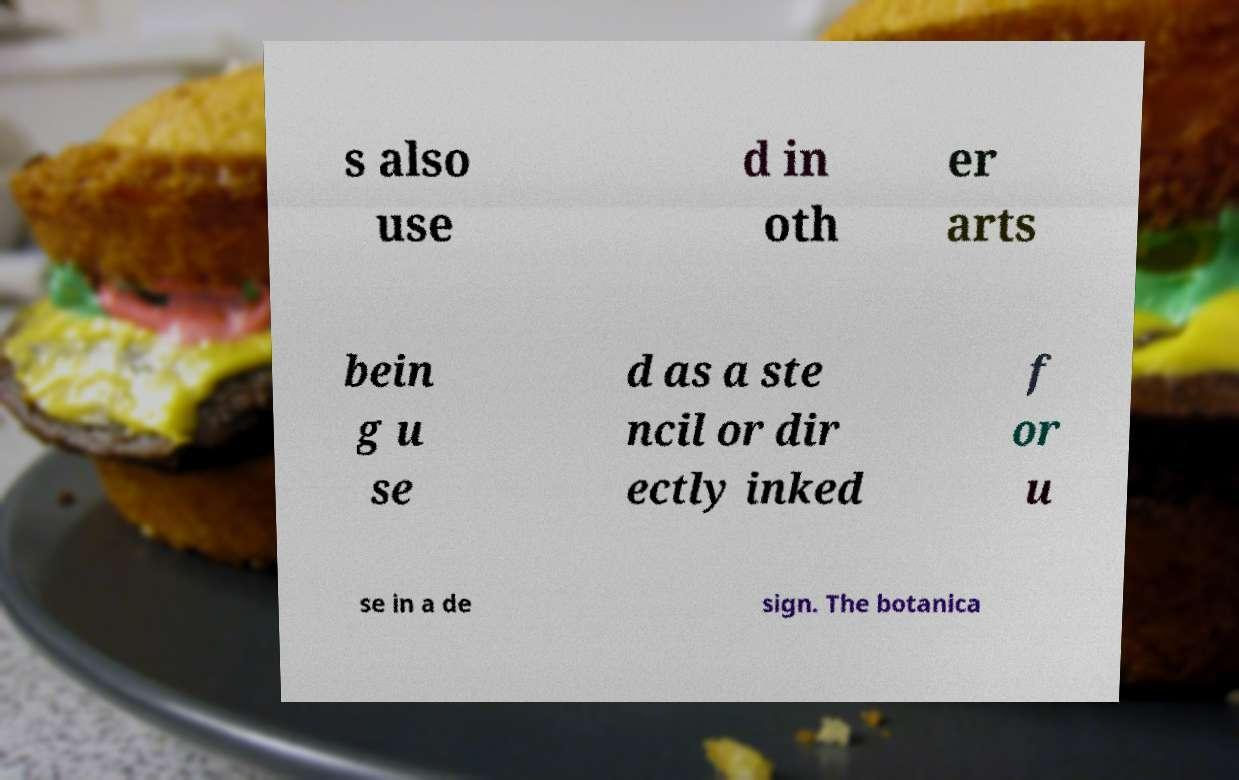Could you assist in decoding the text presented in this image and type it out clearly? s also use d in oth er arts bein g u se d as a ste ncil or dir ectly inked f or u se in a de sign. The botanica 